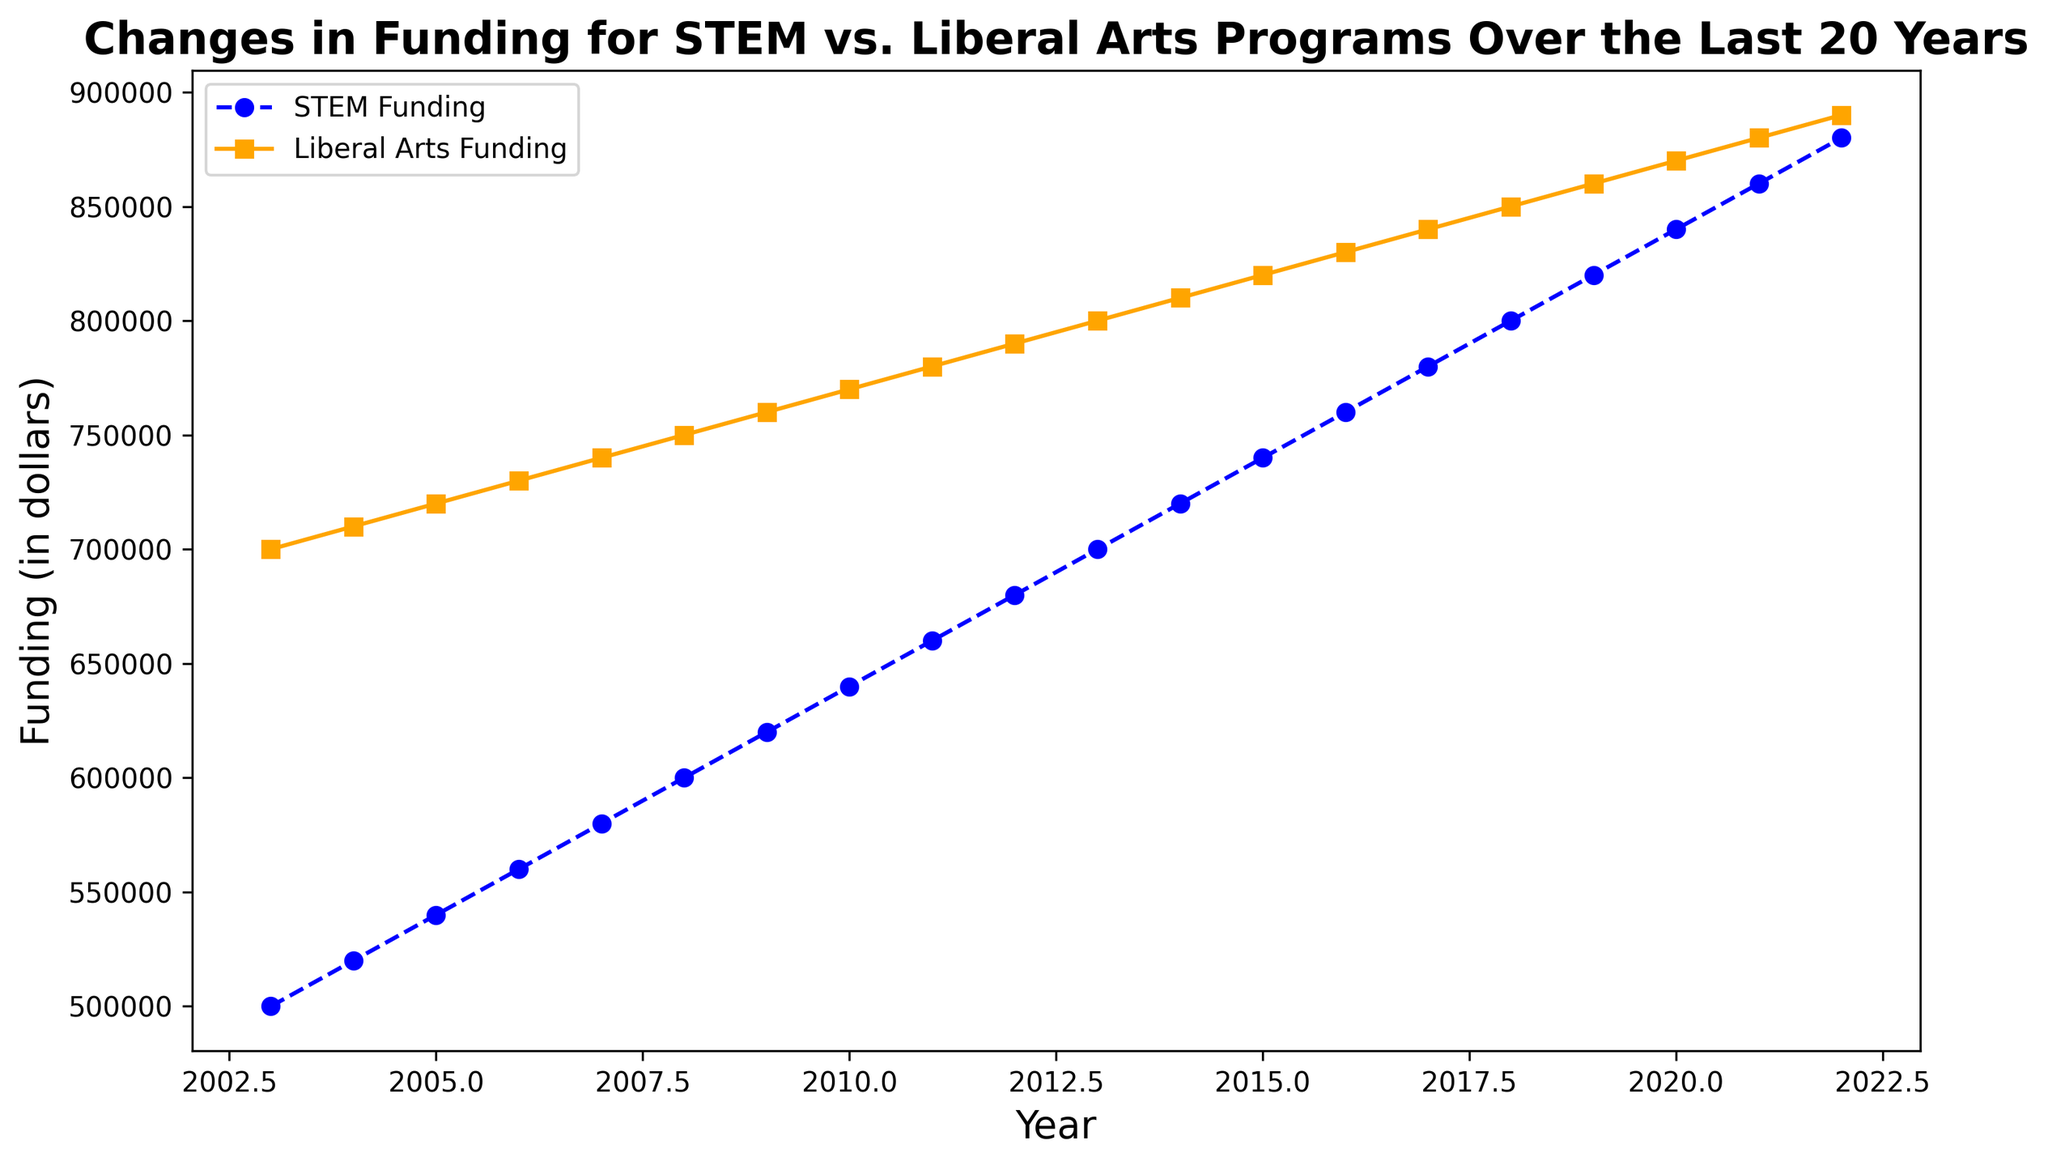Which year shows the highest funding for both STEM and liberal arts programs? Refer to the lines on the plot; both lines peak at the rightmost point corresponding to the year 2022.
Answer: 2022 What is the difference in funding between STEM and liberal arts programs in 2003? Identify the values for STEM and liberal arts in 2003 from the initial points of the lines: STEM = $500,000 and Liberal Arts = $700,000; the difference is $700,000 - $500,000.
Answer: $200,000 By how much did the funding for STEM programs increase from 2003 to 2022? Look at the initial (2003) and final (2022) points on the STEM funding line: initial = $500,000, final = $880,000; the increase is $880,000 - $500,000.
Answer: $380,000 In which year did both the STEM and liberal arts programs reach exactly $800,000 in funding? Find the year where each line crosses the $800,000 funding mark on the vertical axis; STEM crosses in 2013, and Liberal Arts in 2018.
Answer: STEM: 2013, Liberal Arts: 2018 What is the average yearly funding for the liberal arts program over the entire period? Sum all yearly liberal arts funding values (700,000 + 710,000 + ... + 890,000) and divide by the number of years (20); calculate the sum first: (700,000 + 710,000 + 720,000 + 730,000 + 740,000 + 750,000 + 760,000 + 770,000 + 780,000 + 790,000 + 800,000 + 810,000 + 820,000 + 830,000 + 840,000 + 850,000 + 860,000 + 870,000 + 880,000 + 890,000) = 16,000,000; average = 16,000,000 / 20.
Answer: $800,000 By how much did the funding for liberal arts increase between 2008 and 2015? Identify the funding from the lines for 2008 and 2015 for liberal arts: 2008 = $750,000, 2015 = $820,000; the increase is $820,000 - $750,000.
Answer: $70,000 Which program received more funding in 2010, and by how much? Compare the 2010 points on both lines: STEM = $640,000, Liberal Arts = $770,000; the difference is $770,000 - $640,000.
Answer: Liberal Arts by $130,000 What was the funding for STEM programs in 2015 and 2020? What is the percentage increase over this period? Identify the values from the STEM funding line for 2015 and 2020: 2015 = $740,000, 2020 = $840,000; calculate the increase: ($840,000 - $740,000) / $740,000 * 100%.
Answer: 13.51% What is the trend of STEM funding over the 20 years? Observe the shape of the STEM funding line over the years, noting continuous growth.
Answer: Increasing Between which consecutive years did the funding for STEM programs show the greatest increase, and by how much? Analyze the STEM funding line to find the two consecutive years with the steepest slope; the largest increase is between 2021 ($860,000) and 2022 ($880,000): $880,000 - $860,000.
Answer: $20,000 